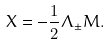<formula> <loc_0><loc_0><loc_500><loc_500>X = { - { \frac { 1 } { 2 } } \Lambda _ { \pm } M . }</formula> 